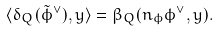<formula> <loc_0><loc_0><loc_500><loc_500>\langle \delta _ { Q } ( \tilde { \phi } ^ { \vee } ) , y \rangle = \beta _ { Q } ( n _ { \phi } \phi ^ { \vee } , y ) .</formula> 